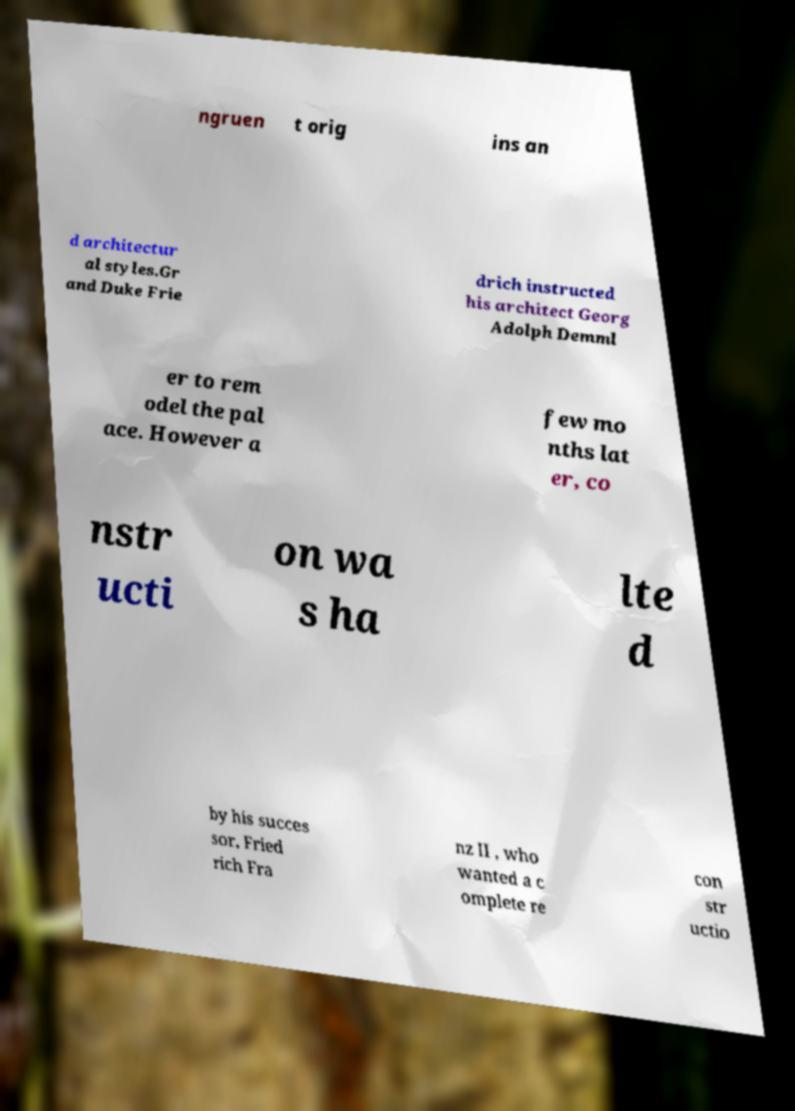Please read and relay the text visible in this image. What does it say? ngruen t orig ins an d architectur al styles.Gr and Duke Frie drich instructed his architect Georg Adolph Demml er to rem odel the pal ace. However a few mo nths lat er, co nstr ucti on wa s ha lte d by his succes sor, Fried rich Fra nz II , who wanted a c omplete re con str uctio 